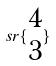<formula> <loc_0><loc_0><loc_500><loc_500>s r \{ \begin{matrix} 4 \\ 3 \end{matrix} \}</formula> 